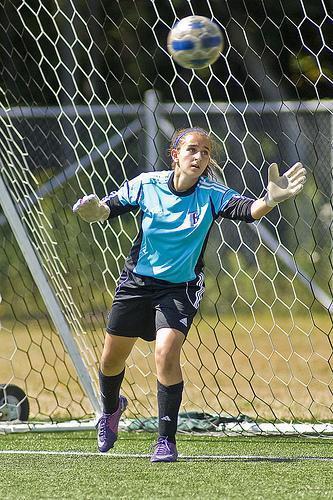How many people are there?
Give a very brief answer. 1. 